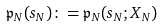Convert formula to latex. <formula><loc_0><loc_0><loc_500><loc_500>\mathfrak { p } _ { N } ( s _ { N } ) \colon = \mathfrak { p } _ { N } ( s _ { N } ; X _ { N } )</formula> 